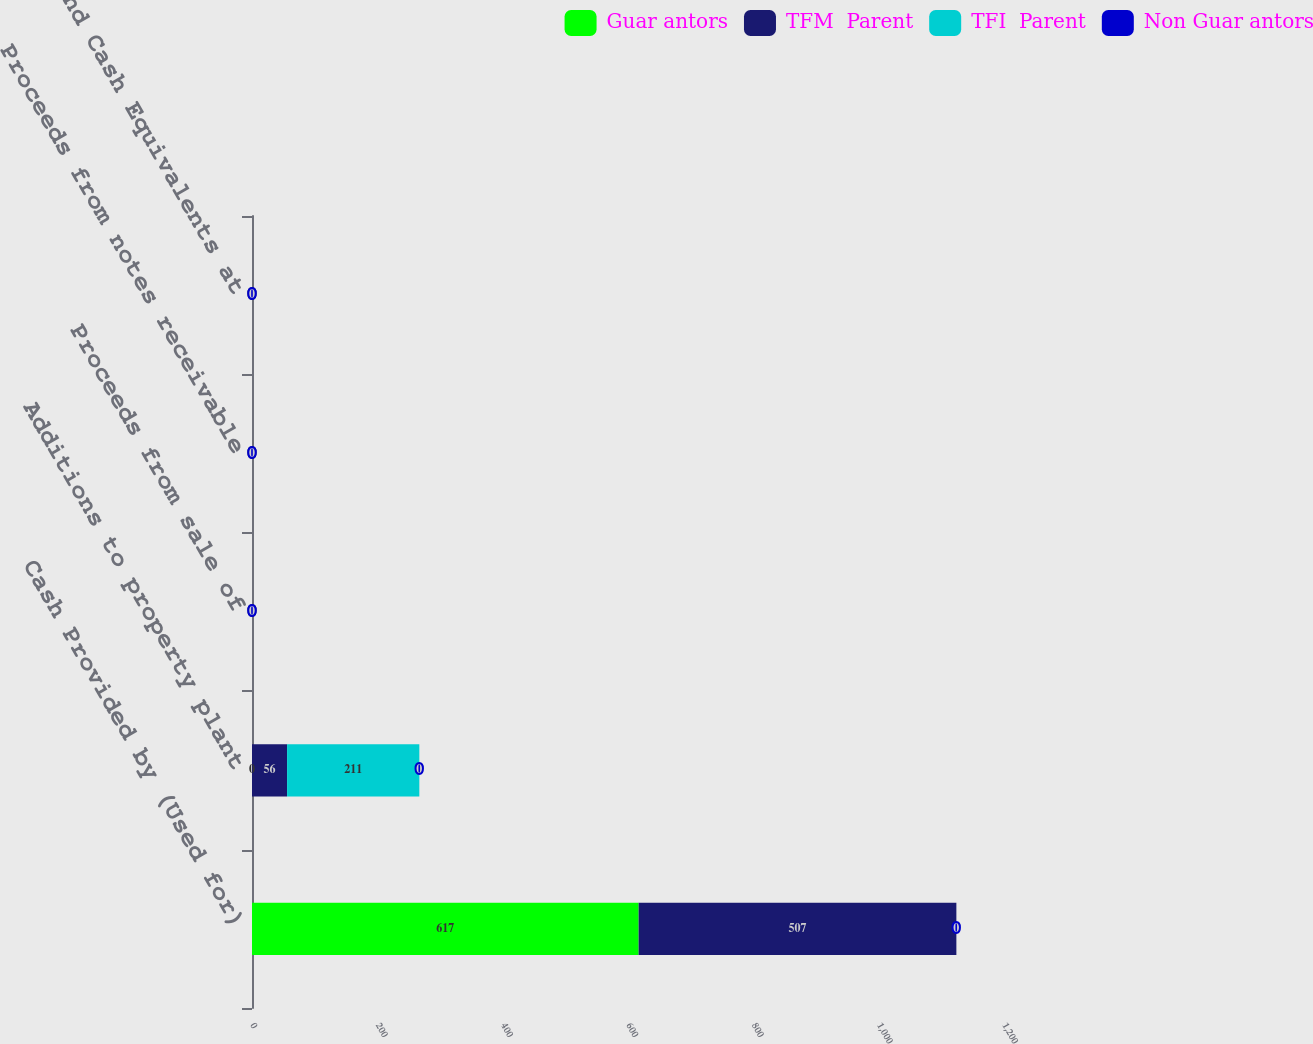Convert chart to OTSL. <chart><loc_0><loc_0><loc_500><loc_500><stacked_bar_chart><ecel><fcel>Cash Provided by (Used for)<fcel>Additions to property plant<fcel>Proceeds from sale of<fcel>Proceeds from notes receivable<fcel>Cash and Cash Equivalents at<nl><fcel>Guar antors<fcel>617<fcel>0<fcel>0<fcel>0<fcel>0<nl><fcel>TFM  Parent<fcel>507<fcel>56<fcel>0<fcel>0<fcel>0<nl><fcel>TFI  Parent<fcel>0<fcel>211<fcel>0<fcel>0<fcel>0<nl><fcel>Non Guar antors<fcel>0<fcel>0<fcel>0<fcel>0<fcel>0<nl></chart> 